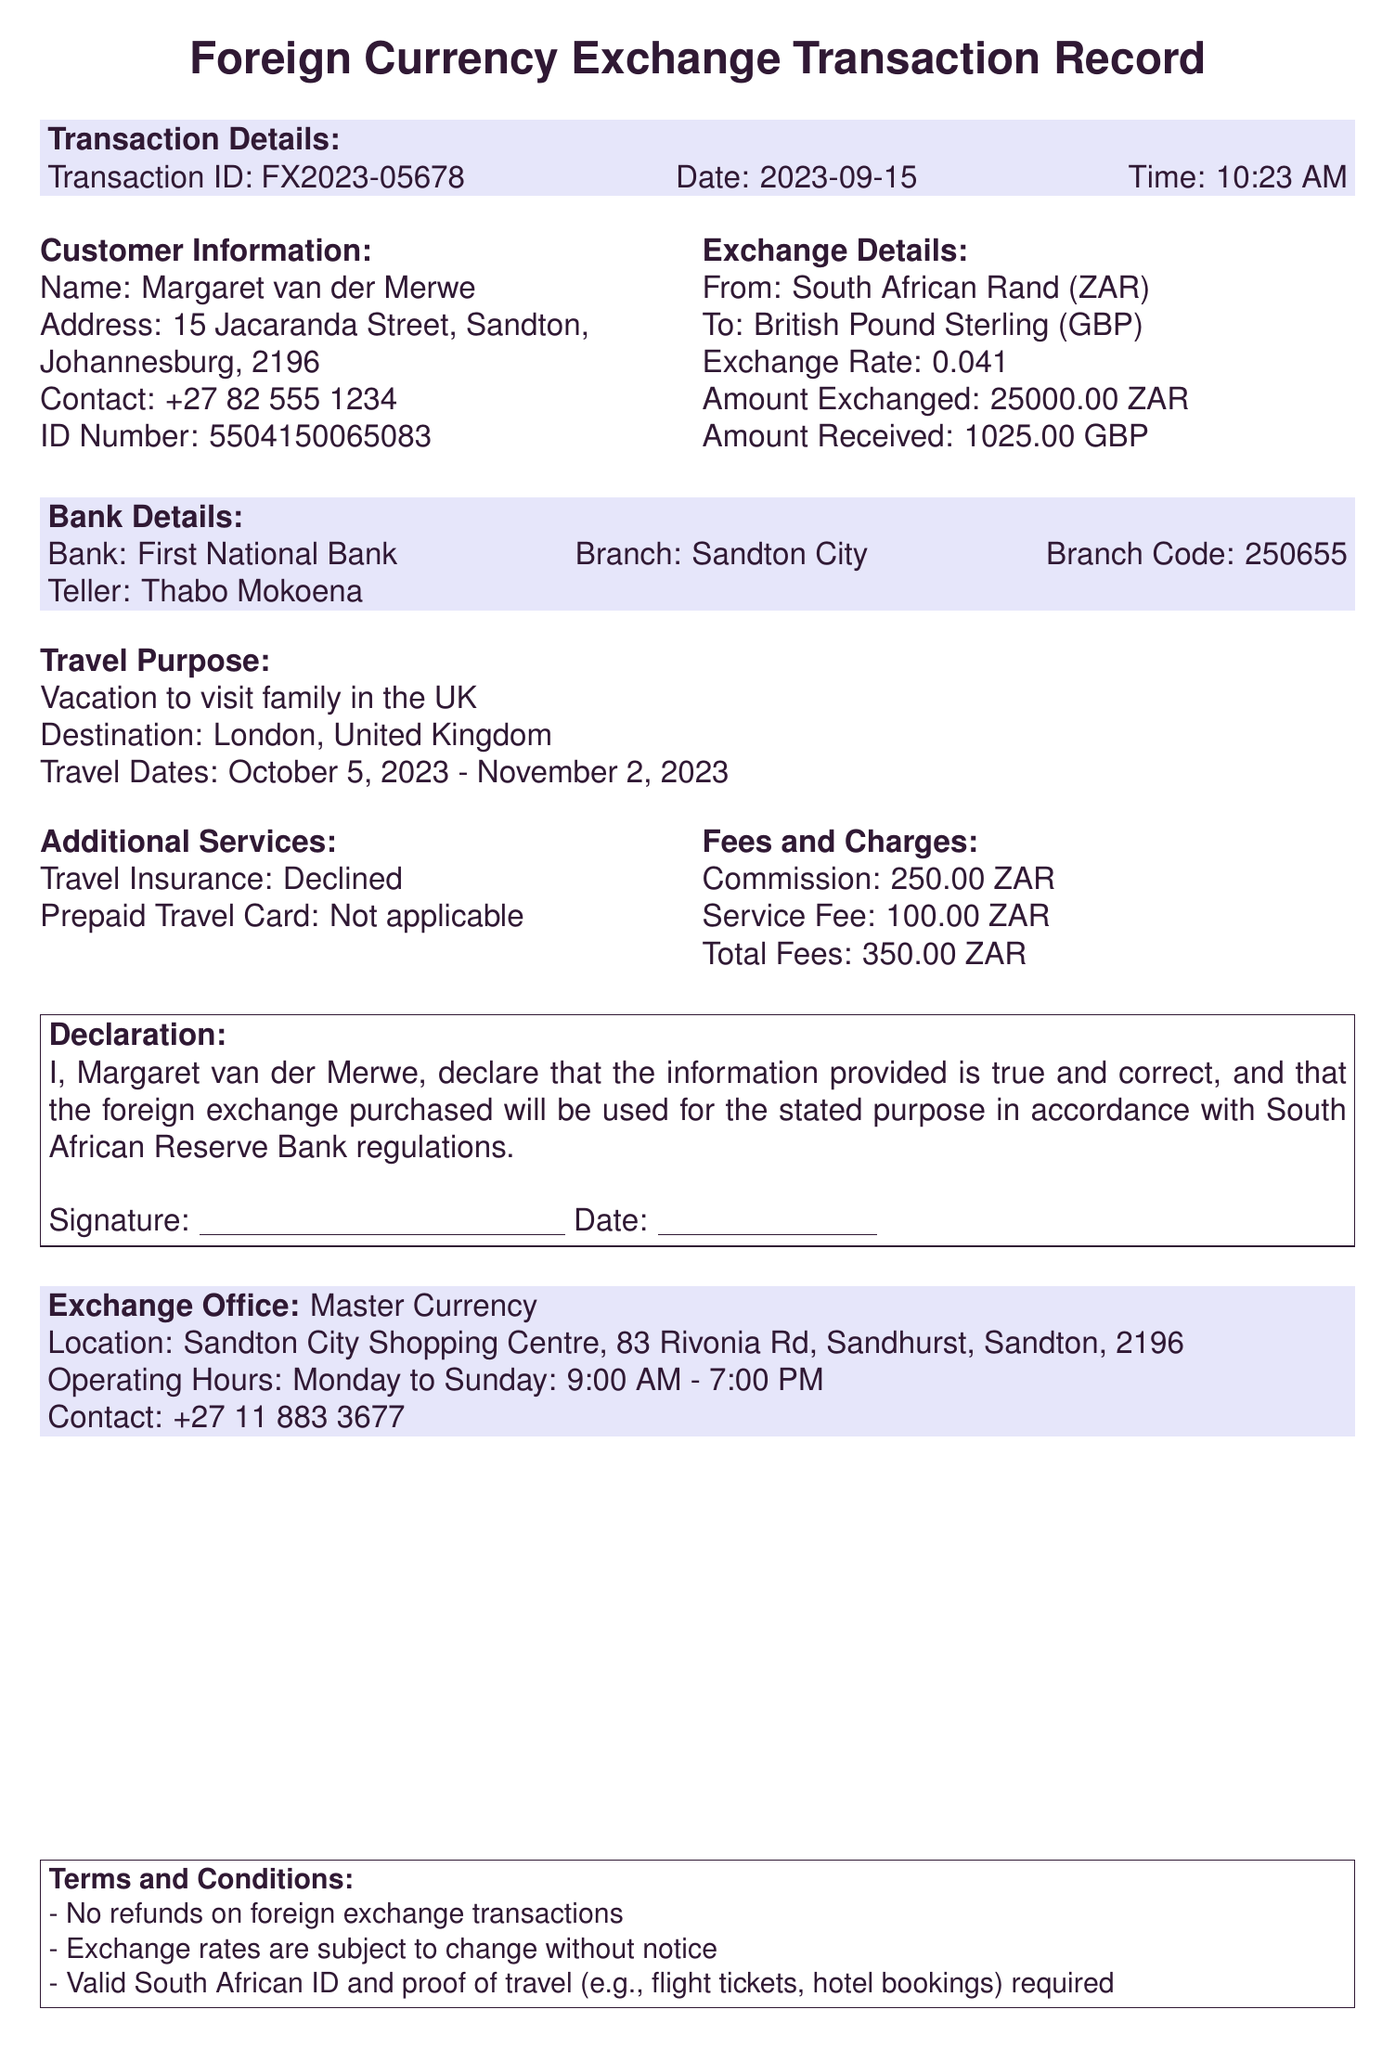What is the transaction ID? The transaction ID is located in the transaction details section.
Answer: FX2023-05678 Who is the customer? The customer's name can be found in the customer information section.
Answer: Margaret van der Merwe What is the amount exchanged in ZAR? The amount exchanged is mentioned in the exchange details section.
Answer: 25000.00 What is the exchange rate? The exchange rate is specified in the exchange details section.
Answer: 0.041 What are the travel dates? The travel dates are listed in the travel purpose section.
Answer: October 5, 2023 - November 2, 2023 Where is the exchange office located? The exchange office location is provided in the exchange office section.
Answer: Sandton City Shopping Centre, 83 Rivonia Rd, Sandhurst, Sandton, 2196 What is the total fee charged for the transaction? The total fees are detailed in the fees and charges section.
Answer: 350.00 ZAR Is travel insurance accepted? The acceptance of travel insurance is indicated in the additional services section.
Answer: Declined What is the reason for this transaction? The reason is stated in the travel purpose section of the document.
Answer: Vacation to visit family in the UK 